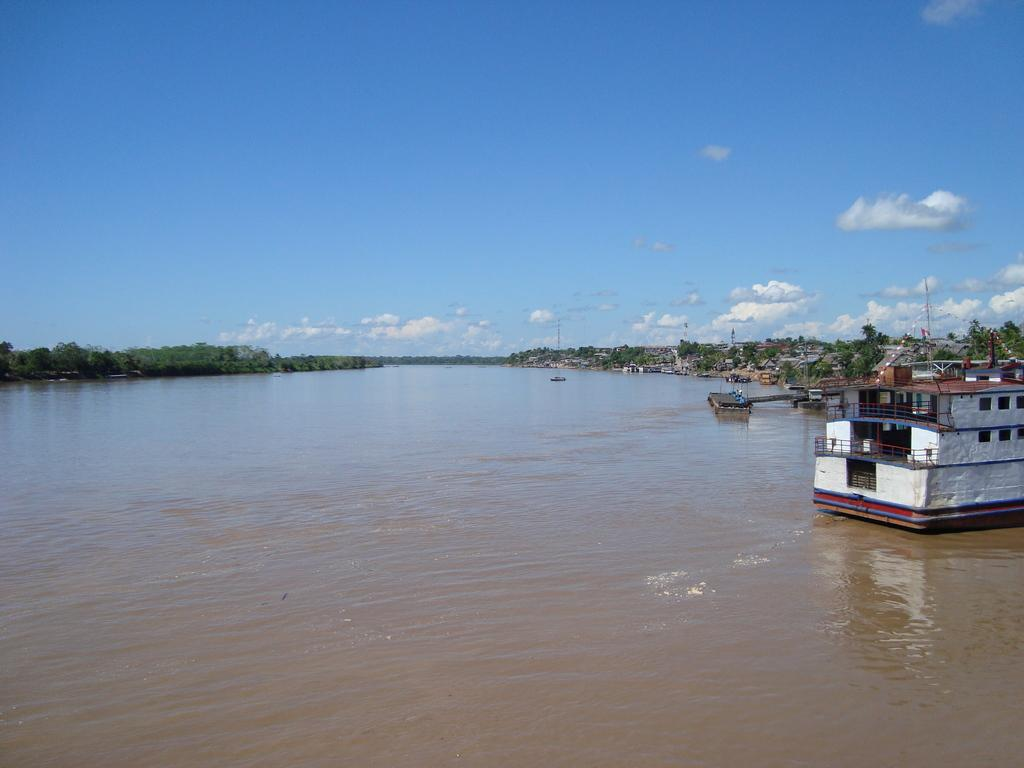What is located on the right side of the image? There is a boat on the right side of the image. Where is the boat situated? The boat is on the water. What can be seen in the background of the image? The sky, clouds, trees, and a few other objects are visible in the background of the image. What time of day is it in the image, based on the hour? The provided facts do not mention the time of day or any specific hour, so it cannot be determined from the image. 